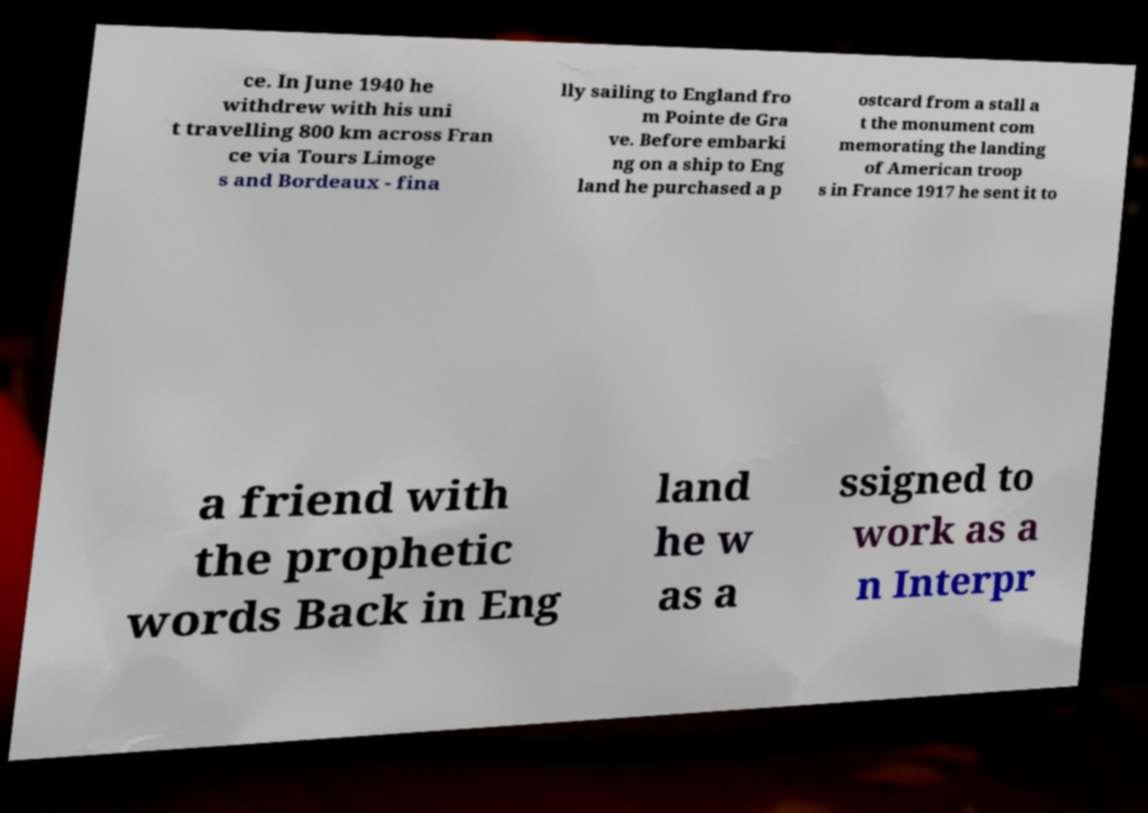Could you extract and type out the text from this image? ce. In June 1940 he withdrew with his uni t travelling 800 km across Fran ce via Tours Limoge s and Bordeaux - fina lly sailing to England fro m Pointe de Gra ve. Before embarki ng on a ship to Eng land he purchased a p ostcard from a stall a t the monument com memorating the landing of American troop s in France 1917 he sent it to a friend with the prophetic words Back in Eng land he w as a ssigned to work as a n Interpr 